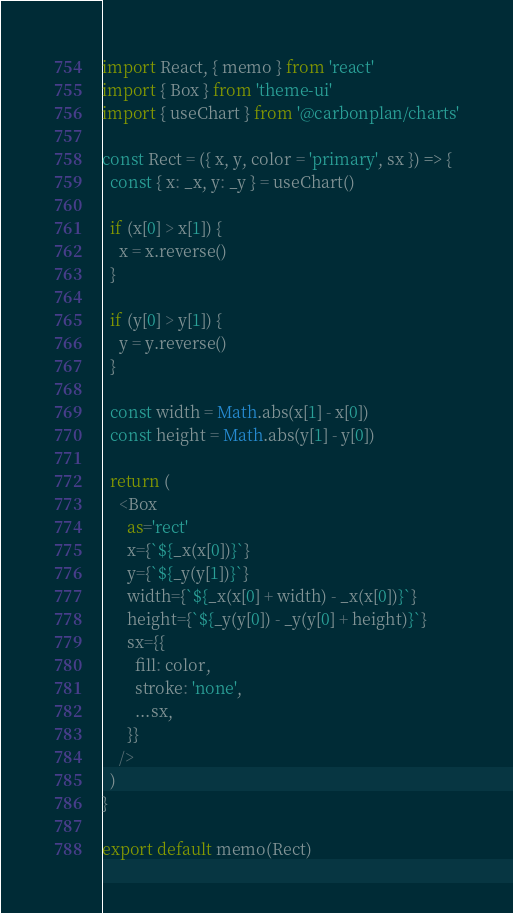<code> <loc_0><loc_0><loc_500><loc_500><_JavaScript_>import React, { memo } from 'react'
import { Box } from 'theme-ui'
import { useChart } from '@carbonplan/charts'

const Rect = ({ x, y, color = 'primary', sx }) => {
  const { x: _x, y: _y } = useChart()

  if (x[0] > x[1]) {
    x = x.reverse()
  }

  if (y[0] > y[1]) {
    y = y.reverse()
  }

  const width = Math.abs(x[1] - x[0])
  const height = Math.abs(y[1] - y[0])

  return (
    <Box
      as='rect'
      x={`${_x(x[0])}`}
      y={`${_y(y[1])}`}
      width={`${_x(x[0] + width) - _x(x[0])}`}
      height={`${_y(y[0]) - _y(y[0] + height)}`}
      sx={{
        fill: color,
        stroke: 'none',
        ...sx,
      }}
    />
  )
}

export default memo(Rect)
</code> 